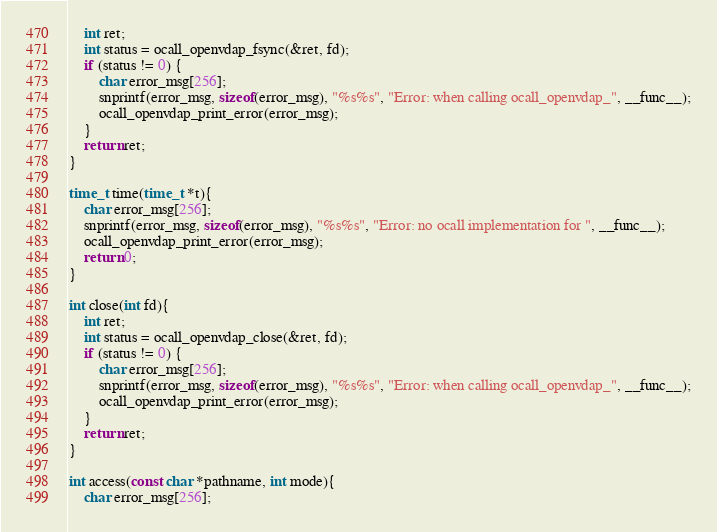<code> <loc_0><loc_0><loc_500><loc_500><_C_>    int ret;
    int status = ocall_openvdap_fsync(&ret, fd);
    if (status != 0) {
        char error_msg[256];
        snprintf(error_msg, sizeof(error_msg), "%s%s", "Error: when calling ocall_openvdap_", __func__);
        ocall_openvdap_print_error(error_msg);
    }
    return ret;
}

time_t time(time_t *t){
    char error_msg[256];
    snprintf(error_msg, sizeof(error_msg), "%s%s", "Error: no ocall implementation for ", __func__);
    ocall_openvdap_print_error(error_msg);
    return 0;
}

int close(int fd){
    int ret;
    int status = ocall_openvdap_close(&ret, fd);
    if (status != 0) {
        char error_msg[256];
        snprintf(error_msg, sizeof(error_msg), "%s%s", "Error: when calling ocall_openvdap_", __func__);
        ocall_openvdap_print_error(error_msg);
    }
    return ret;
}

int access(const char *pathname, int mode){
    char error_msg[256];</code> 